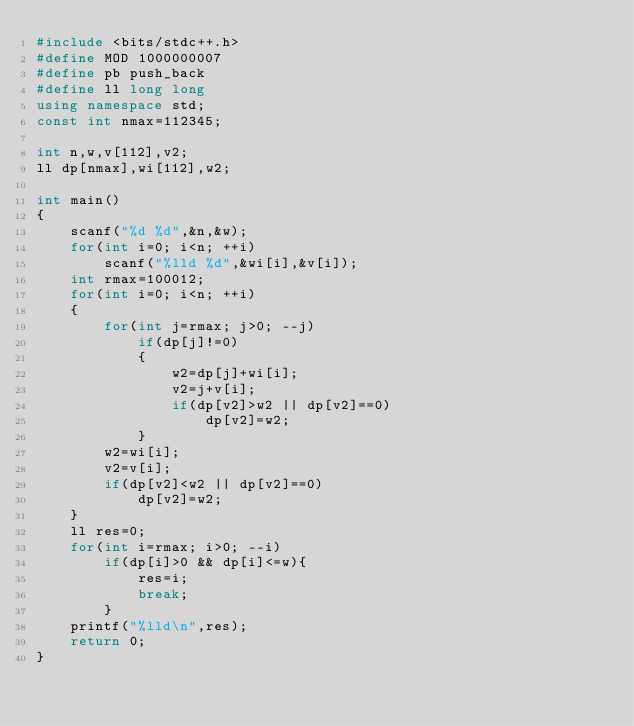<code> <loc_0><loc_0><loc_500><loc_500><_C++_>#include <bits/stdc++.h>
#define MOD 1000000007
#define pb push_back
#define ll long long
using namespace std;
const int nmax=112345;

int n,w,v[112],v2;
ll dp[nmax],wi[112],w2;

int main()
{
    scanf("%d %d",&n,&w);
    for(int i=0; i<n; ++i)
        scanf("%lld %d",&wi[i],&v[i]);
    int rmax=100012;
    for(int i=0; i<n; ++i)
    {
        for(int j=rmax; j>0; --j)
            if(dp[j]!=0)
            {
                w2=dp[j]+wi[i];
                v2=j+v[i];
                if(dp[v2]>w2 || dp[v2]==0)
                    dp[v2]=w2;
            }
        w2=wi[i];
        v2=v[i];
        if(dp[v2]<w2 || dp[v2]==0)
            dp[v2]=w2;
    }
    ll res=0;
    for(int i=rmax; i>0; --i)
        if(dp[i]>0 && dp[i]<=w){
            res=i;
            break;
        }
    printf("%lld\n",res);
    return 0;
}
</code> 